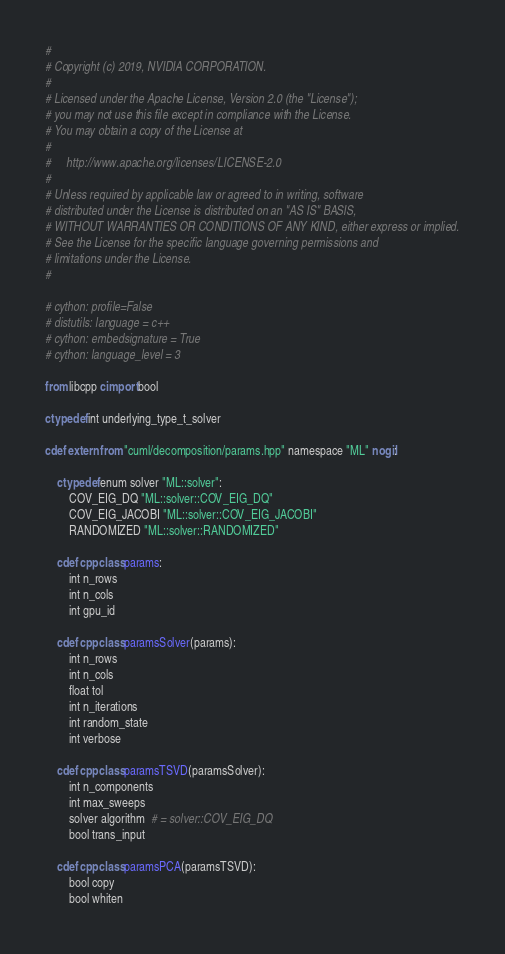<code> <loc_0><loc_0><loc_500><loc_500><_Cython_>#
# Copyright (c) 2019, NVIDIA CORPORATION.
#
# Licensed under the Apache License, Version 2.0 (the "License");
# you may not use this file except in compliance with the License.
# You may obtain a copy of the License at
#
#     http://www.apache.org/licenses/LICENSE-2.0
#
# Unless required by applicable law or agreed to in writing, software
# distributed under the License is distributed on an "AS IS" BASIS,
# WITHOUT WARRANTIES OR CONDITIONS OF ANY KIND, either express or implied.
# See the License for the specific language governing permissions and
# limitations under the License.
#

# cython: profile=False
# distutils: language = c++
# cython: embedsignature = True
# cython: language_level = 3

from libcpp cimport bool

ctypedef int underlying_type_t_solver

cdef extern from "cuml/decomposition/params.hpp" namespace "ML" nogil:

    ctypedef enum solver "ML::solver":
        COV_EIG_DQ "ML::solver::COV_EIG_DQ"
        COV_EIG_JACOBI "ML::solver::COV_EIG_JACOBI"
        RANDOMIZED "ML::solver::RANDOMIZED"

    cdef cppclass params:
        int n_rows
        int n_cols
        int gpu_id

    cdef cppclass paramsSolver(params):
        int n_rows
        int n_cols
        float tol
        int n_iterations
        int random_state
        int verbose

    cdef cppclass paramsTSVD(paramsSolver):
        int n_components
        int max_sweeps
        solver algorithm  # = solver::COV_EIG_DQ
        bool trans_input

    cdef cppclass paramsPCA(paramsTSVD):
        bool copy
        bool whiten
</code> 